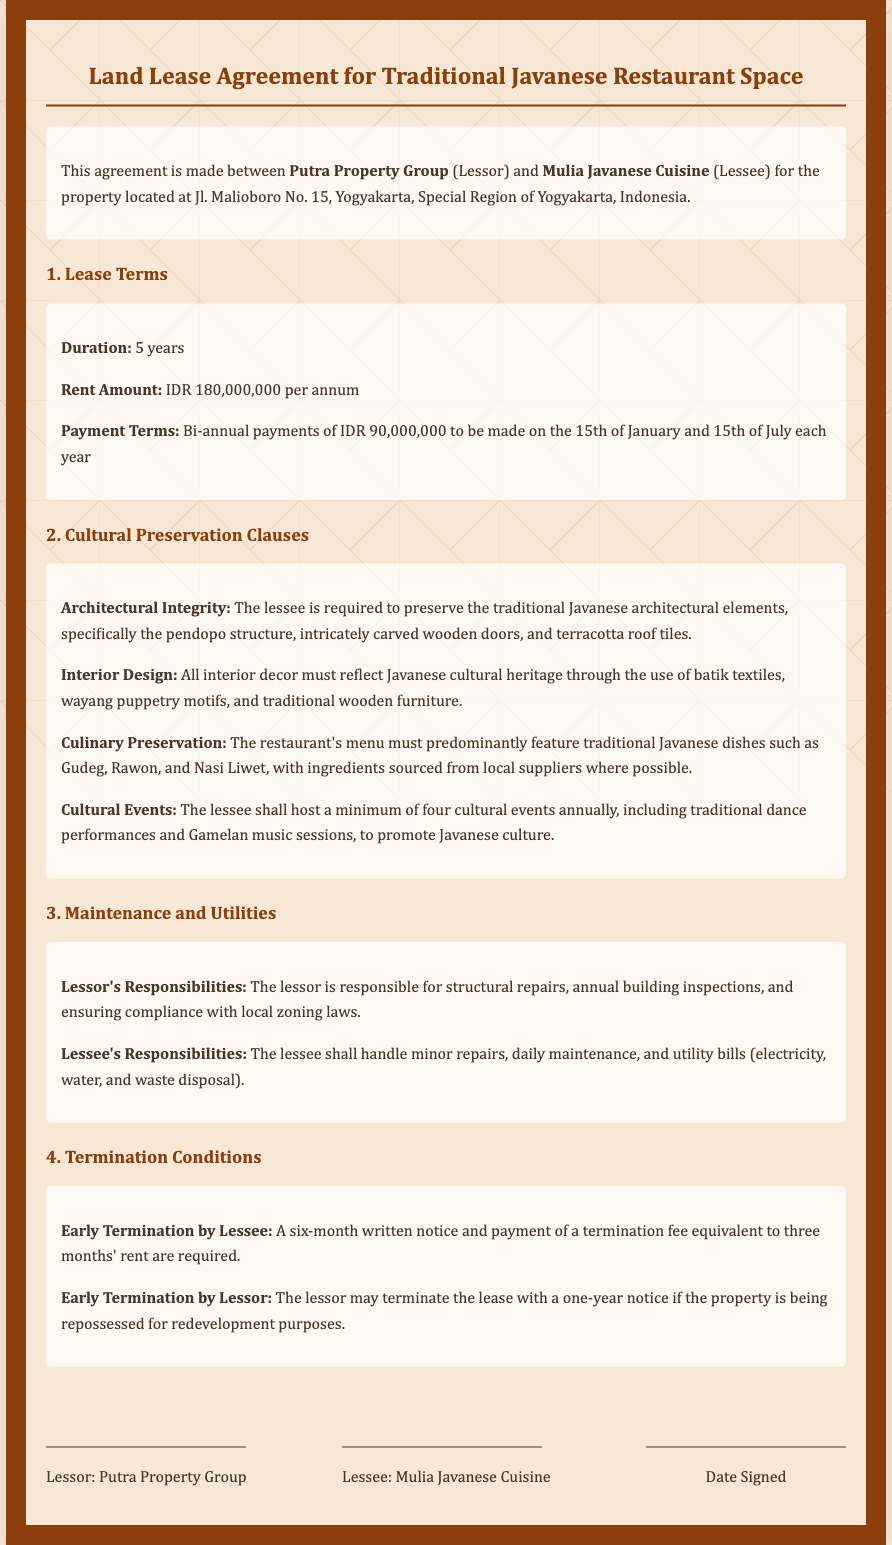What is the duration of the lease? The duration of the lease is specified in the document under Lease Terms.
Answer: 5 years What is the annual rent amount? The document specifies the rent amount in the Lease Terms section.
Answer: IDR 180,000,000 When is the first payment due? The payment terms outline the due dates for rent payments.
Answer: 15th of January What architectural elements must be preserved? The document lists specific architectural elements in the Cultural Preservation Clauses.
Answer: pendopo structure, intricately carved wooden doors, and terracotta roof tiles How many cultural events must be hosted annually? The Cultural Preservation Clauses specify the minimum number of cultural events required.
Answer: four What are the lessee's responsibilities regarding maintenance? The document details the responsibilities of the lessee in the Maintenance and Utilities section.
Answer: Minor repairs, daily maintenance, and utility bills What is required for early termination by the lessee? The conditions for early termination by the lessee are detailed under Termination Conditions.
Answer: Six-month written notice and payment of a termination fee equivalent to three months' rent Who is the lessor in this agreement? The parties involved in the agreement are identified at the beginning of the document.
Answer: Putra Property Group 